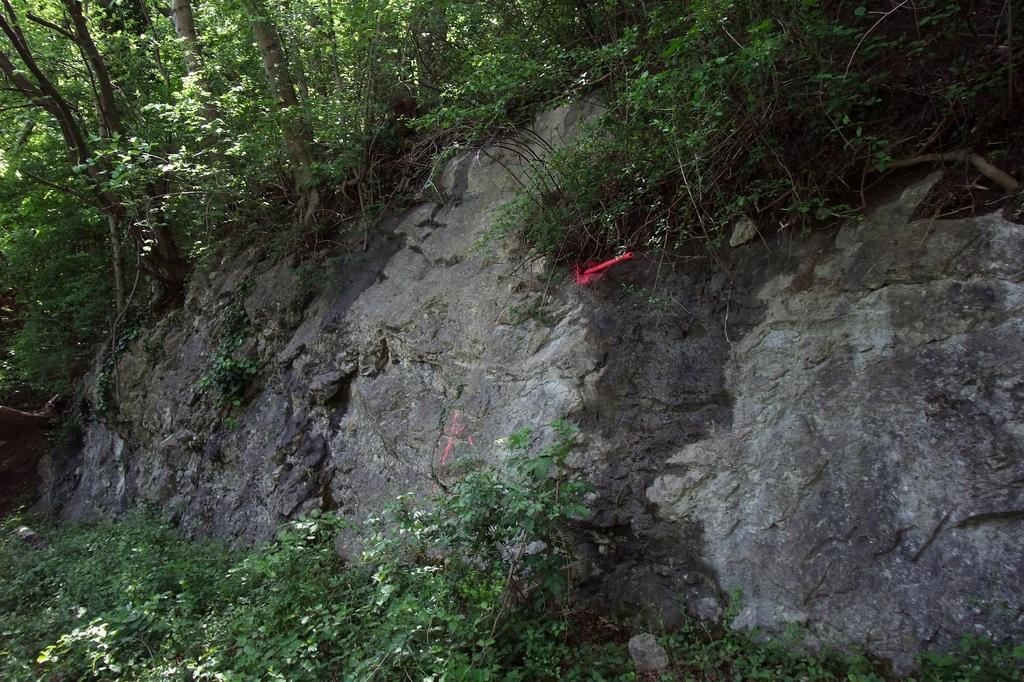What is the main subject in the image? There is a rock in the image. What other natural elements can be seen in the image? There are plants and trees in the image. Can you describe the red object on the rock? There is a red object on the rock, but its purpose or identity is not clear from the image. What type of behavior does the eggnog exhibit in the image? There is no eggnog present in the image, so its behavior cannot be observed or described. 